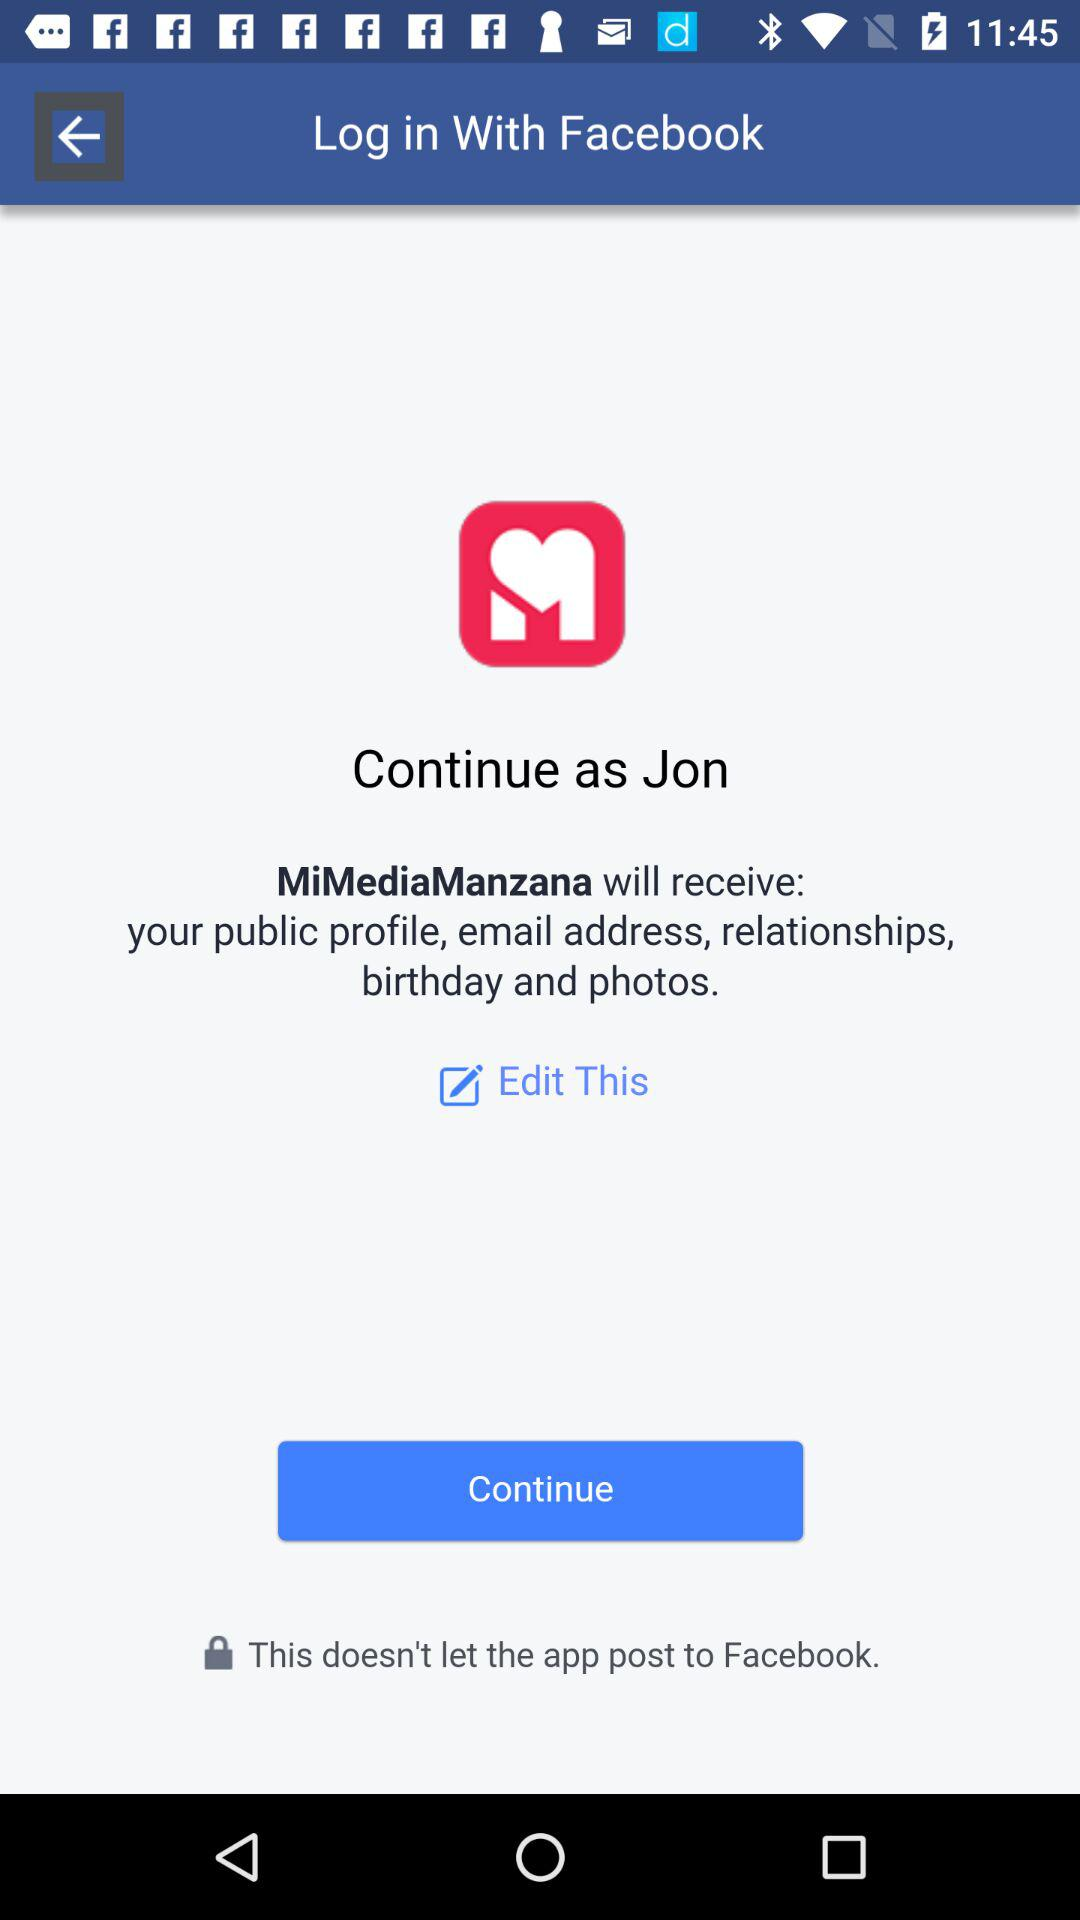Through what application is the person logging in? The person is logging in through the "Facebook" application. 